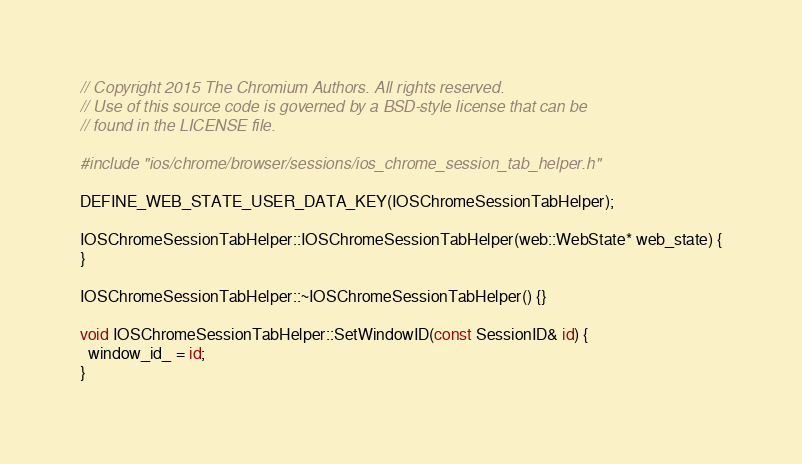Convert code to text. <code><loc_0><loc_0><loc_500><loc_500><_ObjectiveC_>// Copyright 2015 The Chromium Authors. All rights reserved.
// Use of this source code is governed by a BSD-style license that can be
// found in the LICENSE file.

#include "ios/chrome/browser/sessions/ios_chrome_session_tab_helper.h"

DEFINE_WEB_STATE_USER_DATA_KEY(IOSChromeSessionTabHelper);

IOSChromeSessionTabHelper::IOSChromeSessionTabHelper(web::WebState* web_state) {
}

IOSChromeSessionTabHelper::~IOSChromeSessionTabHelper() {}

void IOSChromeSessionTabHelper::SetWindowID(const SessionID& id) {
  window_id_ = id;
}
</code> 